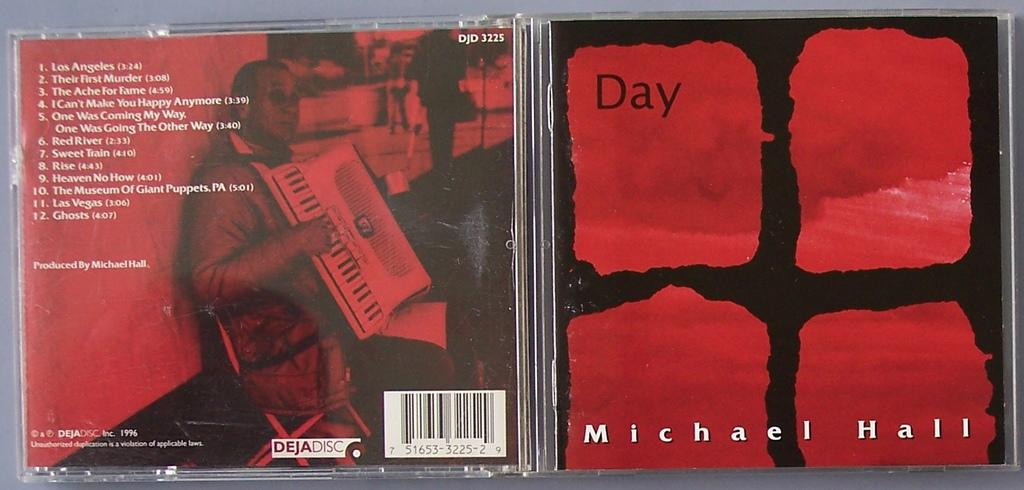<image>
Present a compact description of the photo's key features. A Michael Hall CD has the word "day" on the cover. 